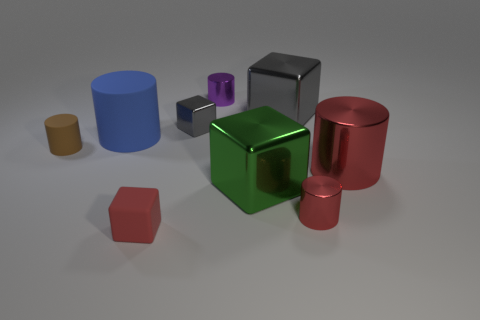Is the number of tiny blocks behind the purple cylinder less than the number of spheres? After observing the image closely, it appears that the number of tiny blocks behind the purple cylinder is not less than the number of spheres. In fact, the actual counts of each are not visible, therefore a definitive comparison cannot be made solely based on this angle. 